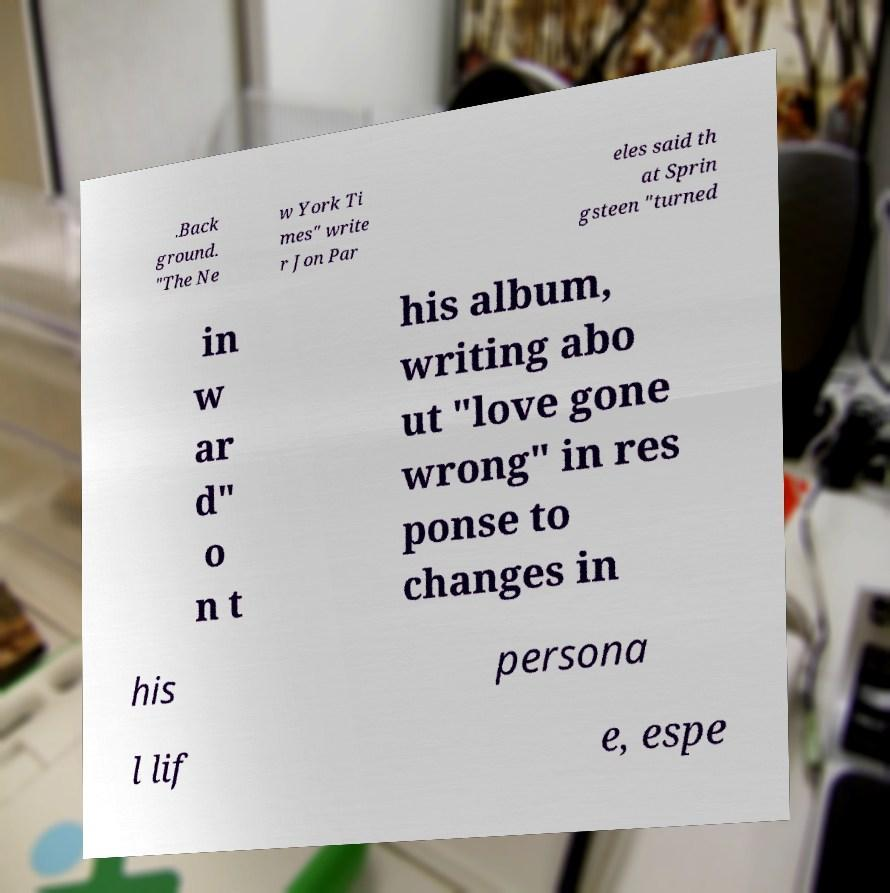I need the written content from this picture converted into text. Can you do that? .Back ground. "The Ne w York Ti mes" write r Jon Par eles said th at Sprin gsteen "turned in w ar d" o n t his album, writing abo ut "love gone wrong" in res ponse to changes in his persona l lif e, espe 